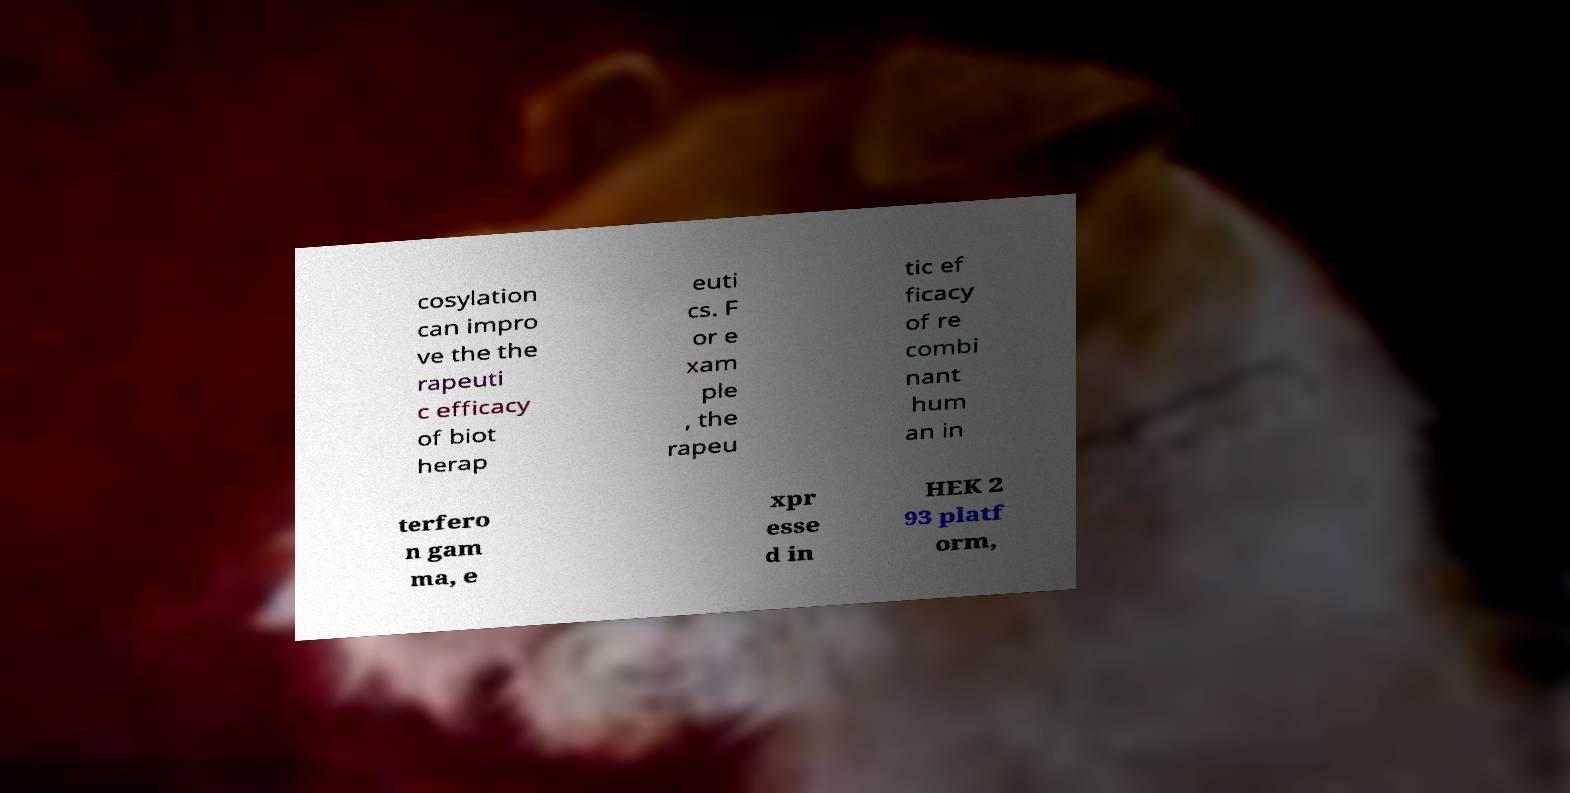Please read and relay the text visible in this image. What does it say? cosylation can impro ve the the rapeuti c efficacy of biot herap euti cs. F or e xam ple , the rapeu tic ef ficacy of re combi nant hum an in terfero n gam ma, e xpr esse d in HEK 2 93 platf orm, 